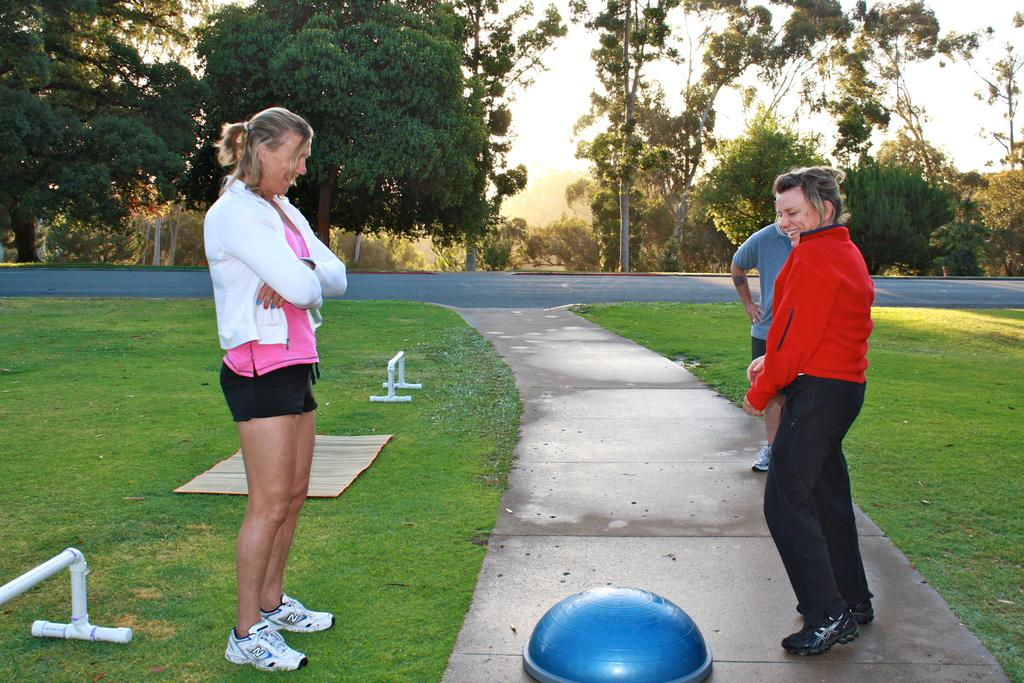What are the people in the image doing? The people in the image are standing on the ground. What can be seen in the background of the image? There are trees and the sky visible in the background of the image. What type of objects can be seen in the image? There are objects in the image, but their specific nature is not mentioned in the facts. What is the surface that the people are standing on? The people are standing on the ground. What else is present in the image besides the people? There is a road and grass present in the image. Can you see any steam coming from the people in the image? There is no mention of steam in the image, so it cannot be determined if any is present. 